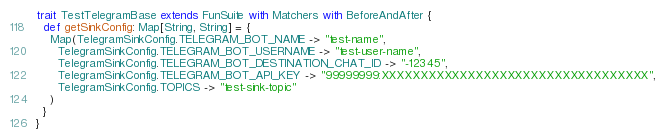<code> <loc_0><loc_0><loc_500><loc_500><_Scala_>trait TestTelegramBase extends FunSuite with Matchers with BeforeAndAfter {
  def getSinkConfig: Map[String, String] = {
    Map(TelegramSinkConfig.TELEGRAM_BOT_NAME -> "test-name",
      TelegramSinkConfig.TELEGRAM_BOT_USERNAME -> "test-user-name",
      TelegramSinkConfig.TELEGRAM_BOT_DESTINATION_CHAT_ID -> "-12345",
      TelegramSinkConfig.TELEGRAM_BOT_API_KEY -> "99999999:XXXXXXXXXXXXXXXXXXXXXXXXXXXXXXXXXX",
      TelegramSinkConfig.TOPICS -> "test-sink-topic"
    )
  }
}
</code> 